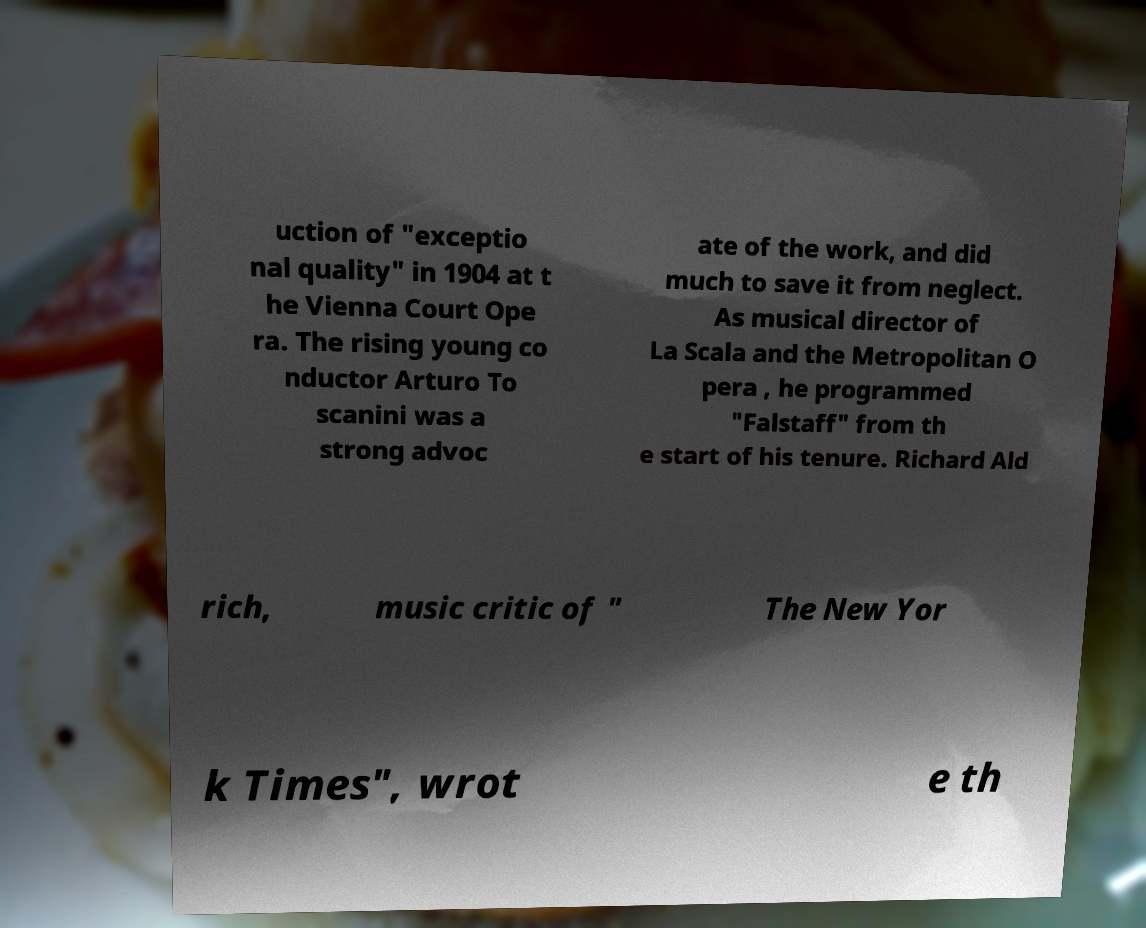Can you read and provide the text displayed in the image?This photo seems to have some interesting text. Can you extract and type it out for me? uction of "exceptio nal quality" in 1904 at t he Vienna Court Ope ra. The rising young co nductor Arturo To scanini was a strong advoc ate of the work, and did much to save it from neglect. As musical director of La Scala and the Metropolitan O pera , he programmed "Falstaff" from th e start of his tenure. Richard Ald rich, music critic of " The New Yor k Times", wrot e th 